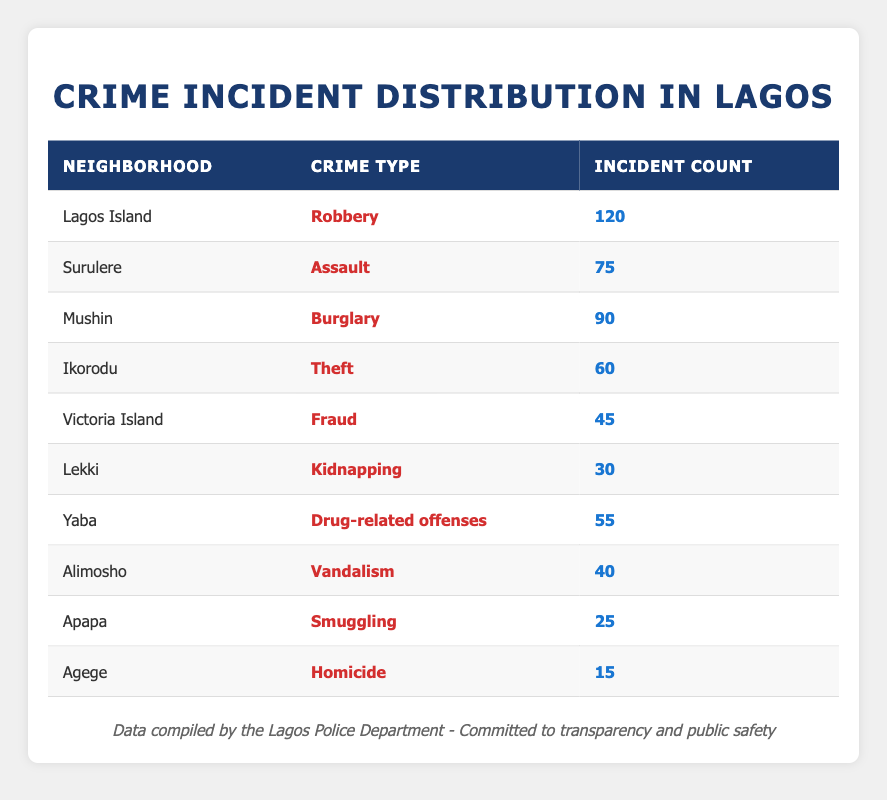What is the crime type with the highest incident count on Lagos Island? The table shows that Lagos Island has a crime type labeled as "Robbery" with an incident count of 120, which is the highest among all neighborhoods listed.
Answer: Robbery In which neighborhood did the second highest number of crimes occur, and what was the crime type? Looking at the table, the second highest incident count is recorded in Mushin, with a crime type of "Burglary" having 90 incidents.
Answer: Mushin, Burglary How many total crime incidents were reported across all neighborhoods? To find the total, we need to sum the incident counts: 120 (Lagos Island) + 75 (Surulere) + 90 (Mushin) + 60 (Ikorodu) + 45 (Victoria Island) + 30 (Lekki) + 55 (Yaba) + 40 (Alimosho) + 25 (Apapa) + 15 (Agege) = 510 total incidents.
Answer: 510 Is there a neighborhood where drug-related offenses had more incidents than homicides? Yes, Yaba has 55 incidents of drug-related offenses, while Agege only had 15 homicides. This means Yaba has significantly more incidents in that category.
Answer: Yes What is the average number of incidents for the neighborhoods listed in the table? To calculate the average, we divide the total incident count (510) by the number of neighborhoods (10). Thus, 510 / 10 = 51.
Answer: 51 Which crime type has the fewest incidents in the neighborhoods of Lagos? Looking at the table, the crime type with the fewest incidents is "Homicide" in Agege, which has a count of 15.
Answer: Homicide Does any neighborhood report incidents of both robbery and assault? No, based on the table data, Lagos Island only reports robbery, and Surulere only reports assault. There is no overlap of reported crime types among the neighborhoods.
Answer: No What is the difference in incident counts between the neighborhoods with the highest and lowest reported crimes? The highest reported crime count is 120 in Lagos Island for robbery, and the lowest is 15 in Agege for homicide. The difference, therefore, is 120 - 15 = 105.
Answer: 105 What proportion of the total crime incidents were related to vandalism? Vandalism incidents in Alimosho total 40. To find the proportion, divide 40 by the total crime incidents (510), which results in about 0.0784. Therefore, the proportion is 7.84%.
Answer: 7.84% 